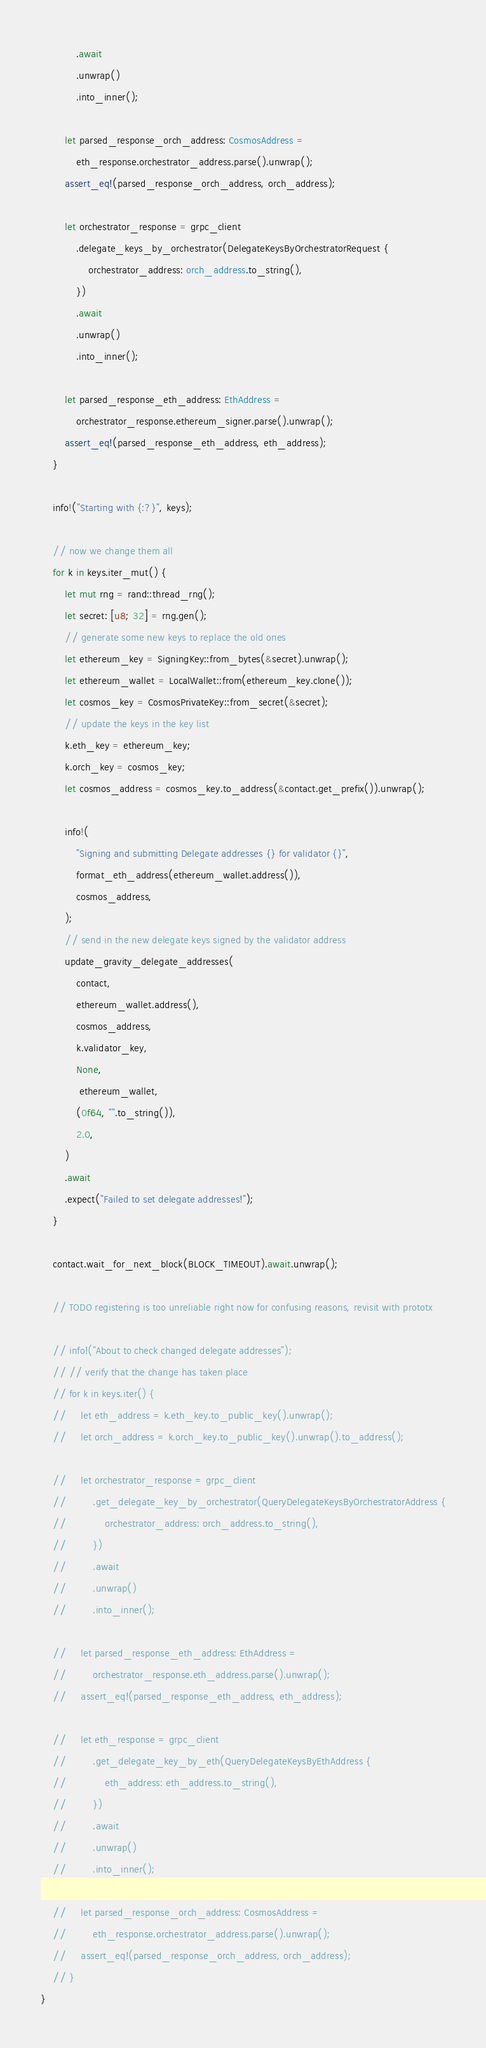Convert code to text. <code><loc_0><loc_0><loc_500><loc_500><_Rust_>            .await
            .unwrap()
            .into_inner();

        let parsed_response_orch_address: CosmosAddress =
            eth_response.orchestrator_address.parse().unwrap();
        assert_eq!(parsed_response_orch_address, orch_address);

        let orchestrator_response = grpc_client
            .delegate_keys_by_orchestrator(DelegateKeysByOrchestratorRequest {
                orchestrator_address: orch_address.to_string(),
            })
            .await
            .unwrap()
            .into_inner();

        let parsed_response_eth_address: EthAddress =
            orchestrator_response.ethereum_signer.parse().unwrap();
        assert_eq!(parsed_response_eth_address, eth_address);
    }

    info!("Starting with {:?}", keys);

    // now we change them all
    for k in keys.iter_mut() {
        let mut rng = rand::thread_rng();
        let secret: [u8; 32] = rng.gen();
        // generate some new keys to replace the old ones
        let ethereum_key = SigningKey::from_bytes(&secret).unwrap();
        let ethereum_wallet = LocalWallet::from(ethereum_key.clone());
        let cosmos_key = CosmosPrivateKey::from_secret(&secret);
        // update the keys in the key list
        k.eth_key = ethereum_key;
        k.orch_key = cosmos_key;
        let cosmos_address = cosmos_key.to_address(&contact.get_prefix()).unwrap();

        info!(
            "Signing and submitting Delegate addresses {} for validator {}",
            format_eth_address(ethereum_wallet.address()),
            cosmos_address,
        );
        // send in the new delegate keys signed by the validator address
        update_gravity_delegate_addresses(
            contact,
            ethereum_wallet.address(),
            cosmos_address,
            k.validator_key,
            None,
             ethereum_wallet,
            (0f64, "".to_string()),
            2.0,
        )
        .await
        .expect("Failed to set delegate addresses!");
    }

    contact.wait_for_next_block(BLOCK_TIMEOUT).await.unwrap();

    // TODO registering is too unreliable right now for confusing reasons, revisit with prototx

    // info!("About to check changed delegate addresses");
    // // verify that the change has taken place
    // for k in keys.iter() {
    //     let eth_address = k.eth_key.to_public_key().unwrap();
    //     let orch_address = k.orch_key.to_public_key().unwrap().to_address();

    //     let orchestrator_response = grpc_client
    //         .get_delegate_key_by_orchestrator(QueryDelegateKeysByOrchestratorAddress {
    //             orchestrator_address: orch_address.to_string(),
    //         })
    //         .await
    //         .unwrap()
    //         .into_inner();

    //     let parsed_response_eth_address: EthAddress =
    //         orchestrator_response.eth_address.parse().unwrap();
    //     assert_eq!(parsed_response_eth_address, eth_address);

    //     let eth_response = grpc_client
    //         .get_delegate_key_by_eth(QueryDelegateKeysByEthAddress {
    //             eth_address: eth_address.to_string(),
    //         })
    //         .await
    //         .unwrap()
    //         .into_inner();

    //     let parsed_response_orch_address: CosmosAddress =
    //         eth_response.orchestrator_address.parse().unwrap();
    //     assert_eq!(parsed_response_orch_address, orch_address);
    // }
}
</code> 